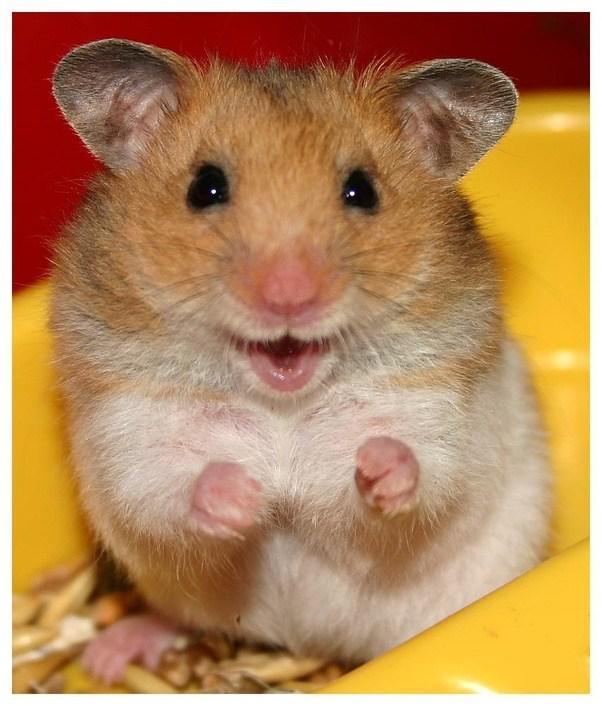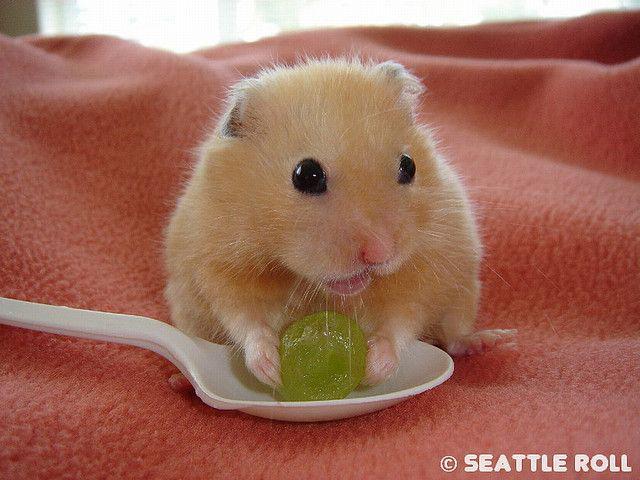The first image is the image on the left, the second image is the image on the right. Considering the images on both sides, is "There are exactly two animals." valid? Answer yes or no. Yes. The first image is the image on the left, the second image is the image on the right. Given the left and right images, does the statement "a hamster is sitting atop draped fabric" hold true? Answer yes or no. Yes. 